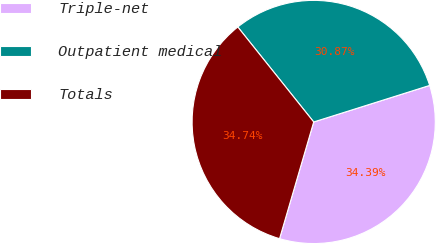Convert chart. <chart><loc_0><loc_0><loc_500><loc_500><pie_chart><fcel>Triple-net<fcel>Outpatient medical<fcel>Totals<nl><fcel>34.39%<fcel>30.87%<fcel>34.74%<nl></chart> 